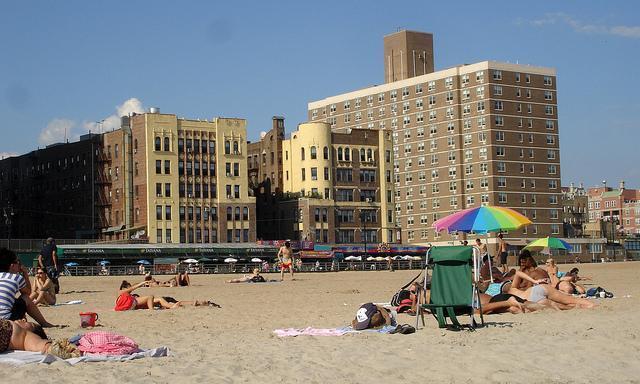How many balconies are visible on the building in the pic?
Give a very brief answer. 0. How many people are there?
Give a very brief answer. 2. How many airplanes are flying to the left of the person?
Give a very brief answer. 0. 